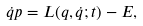Convert formula to latex. <formula><loc_0><loc_0><loc_500><loc_500>\dot { q } p = L ( q , \dot { q } ; t ) - E ,</formula> 